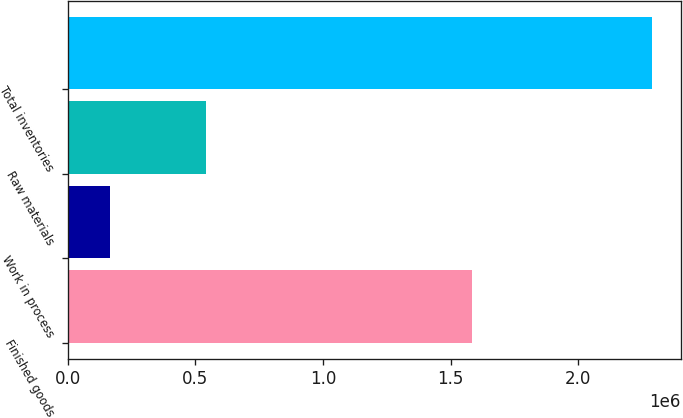Convert chart to OTSL. <chart><loc_0><loc_0><loc_500><loc_500><bar_chart><fcel>Finished goods<fcel>Work in process<fcel>Raw materials<fcel>Total inventories<nl><fcel>1.58211e+06<fcel>165616<fcel>539887<fcel>2.28762e+06<nl></chart> 